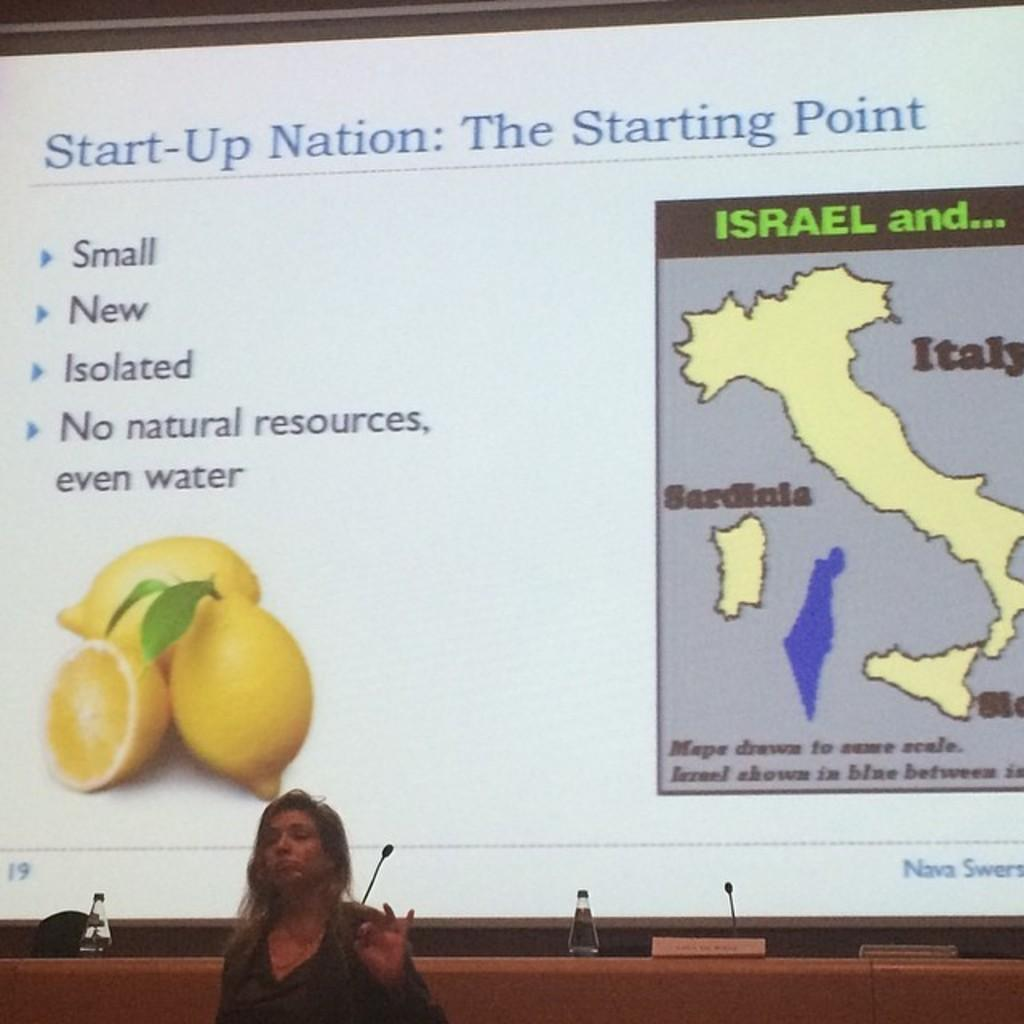What is the main subject of the image? There is a woman standing in the image. What is the purpose of the projector screen in the image? The projector screen displays a picture of lemons. What other item is present near the projector screen? There is a map of Italy beside the projector screen. Can you see a snake slithering across the map of Italy in the image? No, there is no snake present in the image. Is there a kettle visible on the table beside the woman? There is no mention of a kettle in the provided facts, so we cannot determine its presence in the image. 